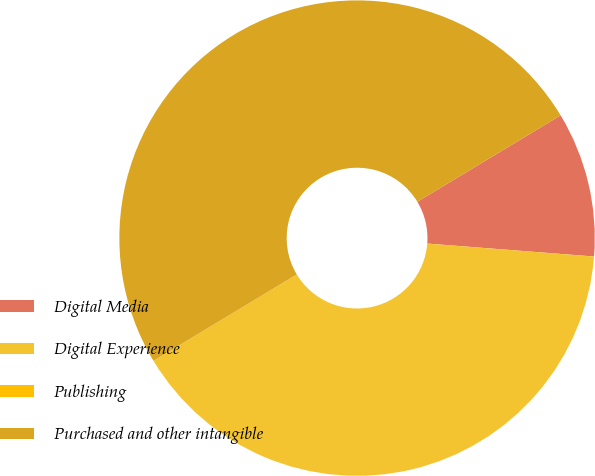Convert chart to OTSL. <chart><loc_0><loc_0><loc_500><loc_500><pie_chart><fcel>Digital Media<fcel>Digital Experience<fcel>Publishing<fcel>Purchased and other intangible<nl><fcel>9.87%<fcel>40.13%<fcel>0.0%<fcel>50.0%<nl></chart> 